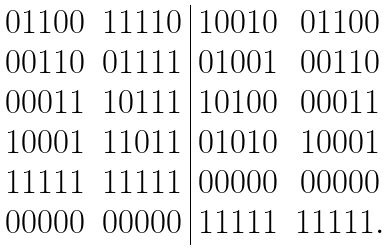Convert formula to latex. <formula><loc_0><loc_0><loc_500><loc_500>\begin{array} { c c | c c } 0 1 1 0 0 & 1 1 1 1 0 & 1 0 0 1 0 & 0 1 1 0 0 \\ 0 0 1 1 0 & 0 1 1 1 1 & 0 1 0 0 1 & 0 0 1 1 0 \\ 0 0 0 1 1 & 1 0 1 1 1 & 1 0 1 0 0 & 0 0 0 1 1 \\ 1 0 0 0 1 & 1 1 0 1 1 & 0 1 0 1 0 & 1 0 0 0 1 \\ 1 1 1 1 1 & 1 1 1 1 1 & 0 0 0 0 0 & 0 0 0 0 0 \\ 0 0 0 0 0 & 0 0 0 0 0 & 1 1 1 1 1 & 1 1 1 1 1 . \end{array}</formula> 